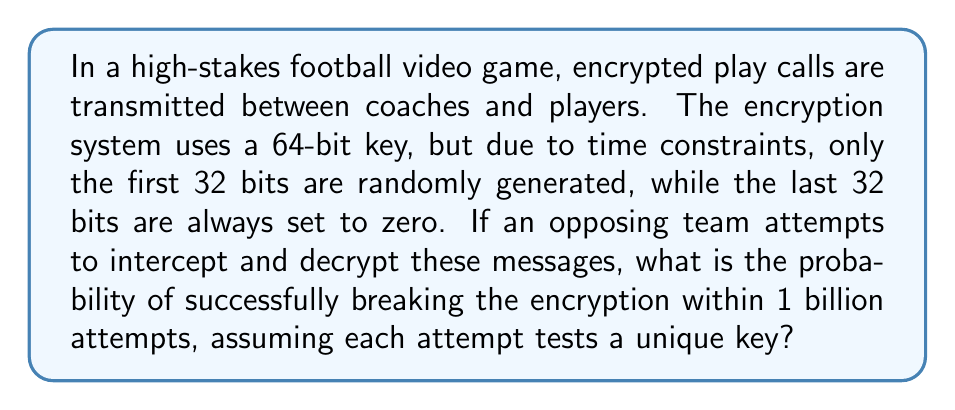Could you help me with this problem? Let's approach this step-by-step:

1) First, we need to calculate the total number of possible keys:
   - There are 32 bits that can vary (the first half of the key)
   - Each bit can be either 0 or 1
   - So, the total number of possible keys is $2^{32}$

2) The probability of guessing the correct key in a single attempt is:

   $$P(\text{single success}) = \frac{1}{2^{32}}$$

3) The probability of not guessing the correct key in a single attempt is:

   $$P(\text{single failure}) = 1 - \frac{1}{2^{32}}$$

4) For n attempts, the probability of failing all n times is:

   $$P(\text{all failures}) = (1 - \frac{1}{2^{32}})^n$$

5) Therefore, the probability of succeeding at least once in n attempts is:

   $$P(\text{at least one success}) = 1 - (1 - \frac{1}{2^{32}})^n$$

6) In this case, n = 1 billion = $10^9$

7) Plugging this into our equation:

   $$P(\text{success}) = 1 - (1 - \frac{1}{2^{32}})^{10^9}$$

8) Using a calculator or computer (as this is a complex calculation):

   $$P(\text{success}) \approx 0.2321$$

This means there's approximately a 23.21% chance of breaking the encryption within 1 billion attempts.
Answer: $\approx 0.2321$ or $23.21\%$ 